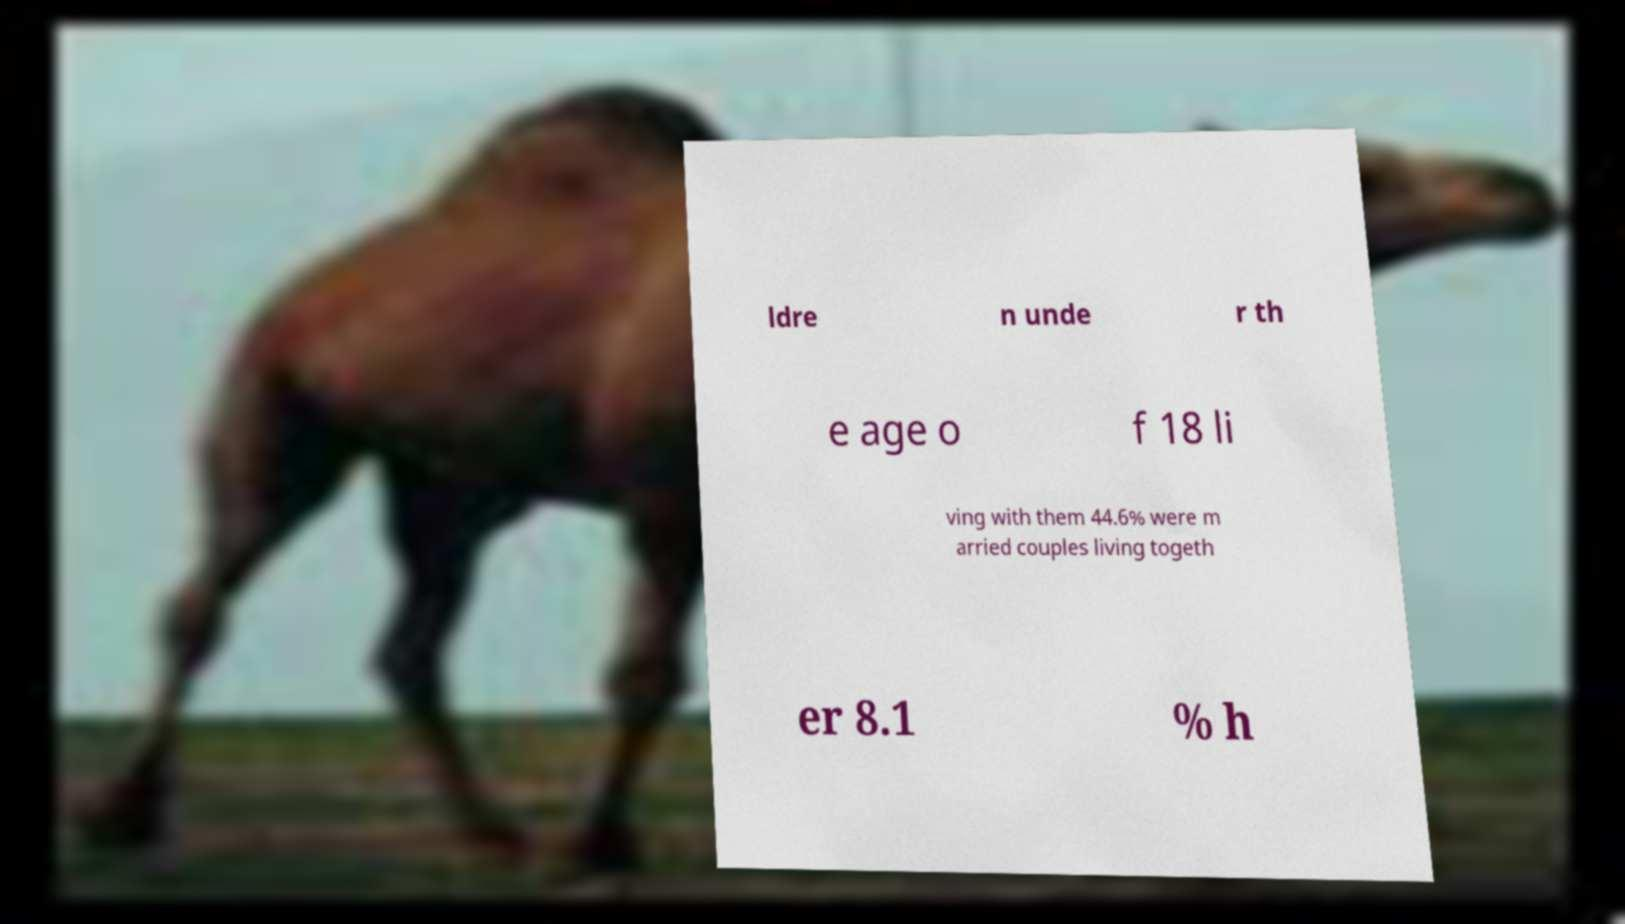For documentation purposes, I need the text within this image transcribed. Could you provide that? ldre n unde r th e age o f 18 li ving with them 44.6% were m arried couples living togeth er 8.1 % h 